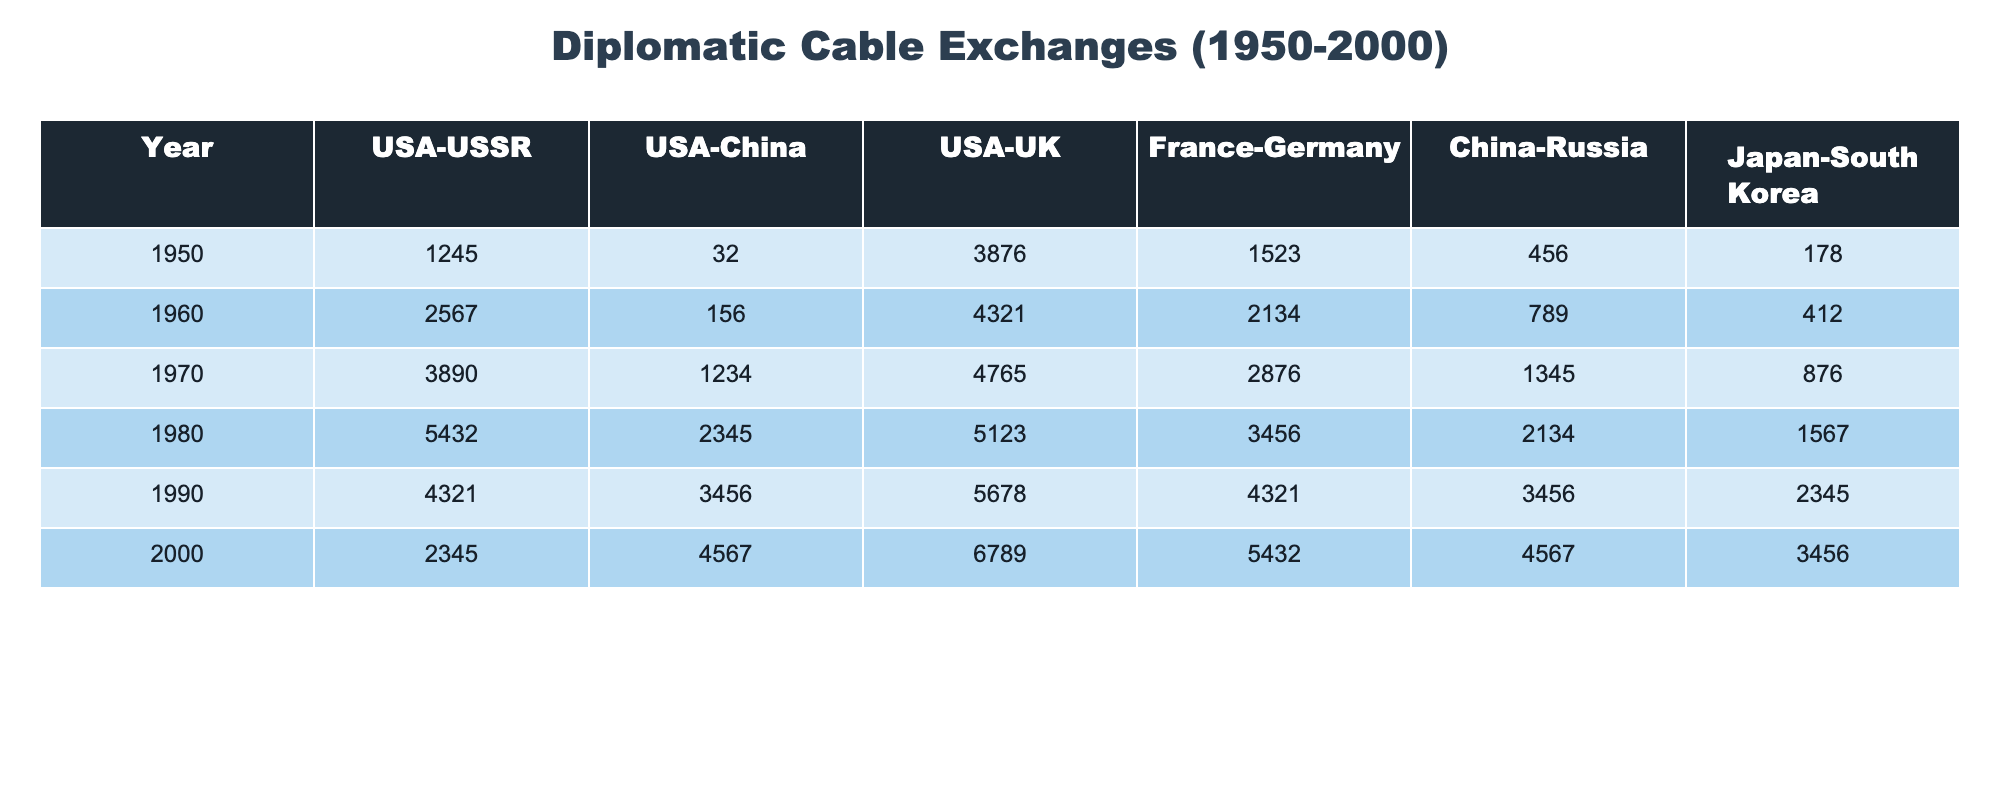What was the total number of diplomatic cable exchanges between the USA and the USSR in 1980? In 1980, the number of diplomatic cable exchanges between the USA and the USSR is given as 5432. Therefore, the total is simply this value.
Answer: 5432 Which year saw the highest number of diplomatic cable exchanges between the USA and the UK? Looking through the data, the exchanges for the USA and the UK were as follows: 3876 in 1950, 4321 in 1960, 4765 in 1970, 5123 in 1980, 5678 in 1990, and 6789 in 2000. The highest value is 6789 in the year 2000.
Answer: 6789 What is the average number of diplomatic cable exchanges between China and Russia from 1950 to 2000? The exchanges between China and Russia across six years are: 456, 789, 1345, 2134, 3456, and 4567. Adding these gives a total of 13457. Dividing by the number of years (6) gives an average of 2242.83, which rounds to 2243.
Answer: 2243 Did the USA have more diplomatic cable exchanges with China than with the USSR in 1990? In 1990, the USA had 3456 exchanges with China and 4321 with the USSR. Since 3456 is less than 4321, the statement is false.
Answer: No In which year did the USA have the least number of diplomatic cable exchanges with China? Looking at the exchanges with China from the years provided: 32 in 1950, 156 in 1960, 1234 in 1970, 2345 in 1980, 3456 in 1990, and 4567 in 2000, the least value is 32 in 1950.
Answer: 1950 What is the difference in cable exchanges between Japan and South Korea in the year 2000 compared to 1950? In 2000, the exchanges between Japan and South Korea were 3456, and in 1950, they were 178. The difference is 3456 - 178 = 3278.
Answer: 3278 Which pair had the most significant increase in diplomatic cable exchanges from 1950 to 2000? To find the most significant increase, we calculate the differences for each pair: USA-USSR increased by 1090, USA-China by 4535, USA-UK by 2903, France-Germany by 3919, China-Russia by 4111, and Japan-South Korea by 3378. The greatest increase is in USA-China with 4535.
Answer: USA-China Is it true that France and Germany had fewer diplomatic cable exchanges than the USA and UK in any year? Comparing the values, in every year except 2000 (where France-Germany had 5432 while USA-UK had 6789), France-Germany had less. Thus, the statement is true for all years before 2000.
Answer: Yes 